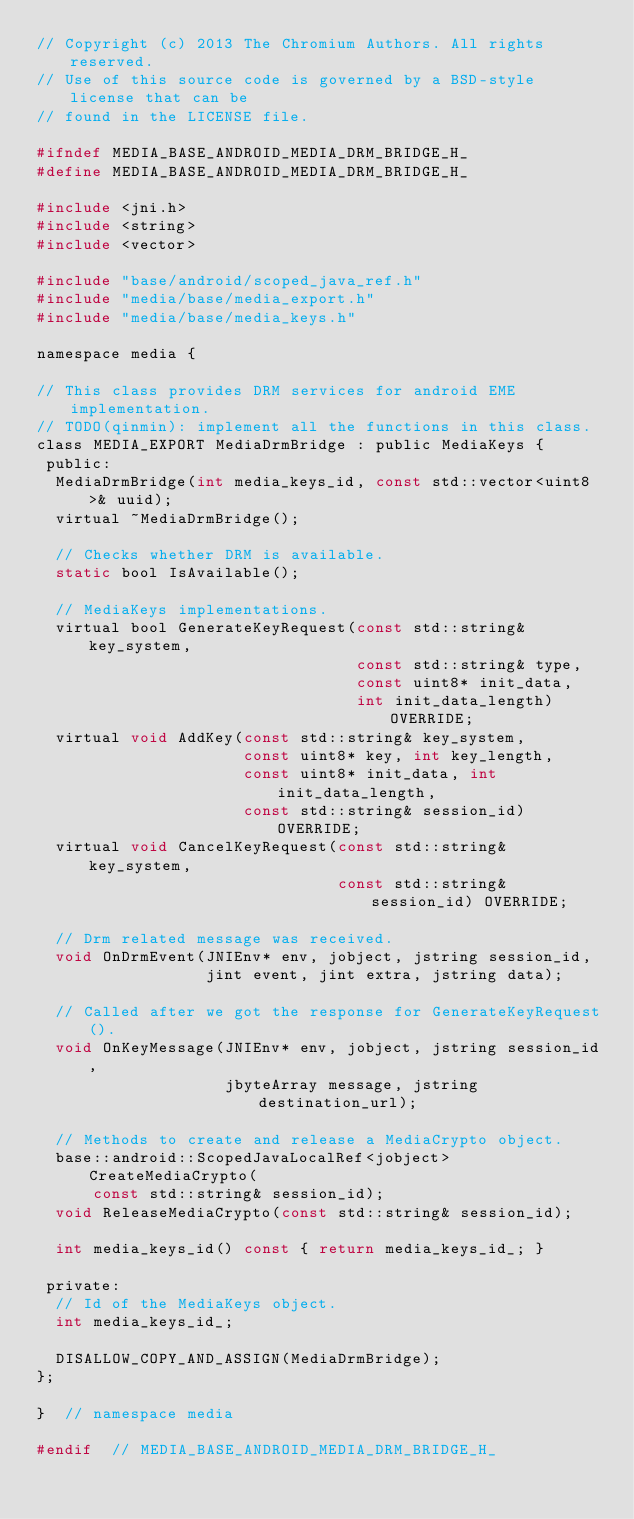Convert code to text. <code><loc_0><loc_0><loc_500><loc_500><_C_>// Copyright (c) 2013 The Chromium Authors. All rights reserved.
// Use of this source code is governed by a BSD-style license that can be
// found in the LICENSE file.

#ifndef MEDIA_BASE_ANDROID_MEDIA_DRM_BRIDGE_H_
#define MEDIA_BASE_ANDROID_MEDIA_DRM_BRIDGE_H_

#include <jni.h>
#include <string>
#include <vector>

#include "base/android/scoped_java_ref.h"
#include "media/base/media_export.h"
#include "media/base/media_keys.h"

namespace media {

// This class provides DRM services for android EME implementation.
// TODO(qinmin): implement all the functions in this class.
class MEDIA_EXPORT MediaDrmBridge : public MediaKeys {
 public:
  MediaDrmBridge(int media_keys_id, const std::vector<uint8>& uuid);
  virtual ~MediaDrmBridge();

  // Checks whether DRM is available.
  static bool IsAvailable();

  // MediaKeys implementations.
  virtual bool GenerateKeyRequest(const std::string& key_system,
                                  const std::string& type,
                                  const uint8* init_data,
                                  int init_data_length) OVERRIDE;
  virtual void AddKey(const std::string& key_system,
                      const uint8* key, int key_length,
                      const uint8* init_data, int init_data_length,
                      const std::string& session_id) OVERRIDE;
  virtual void CancelKeyRequest(const std::string& key_system,
                                const std::string& session_id) OVERRIDE;

  // Drm related message was received.
  void OnDrmEvent(JNIEnv* env, jobject, jstring session_id,
                  jint event, jint extra, jstring data);

  // Called after we got the response for GenerateKeyRequest().
  void OnKeyMessage(JNIEnv* env, jobject, jstring session_id,
                    jbyteArray message, jstring destination_url);

  // Methods to create and release a MediaCrypto object.
  base::android::ScopedJavaLocalRef<jobject> CreateMediaCrypto(
      const std::string& session_id);
  void ReleaseMediaCrypto(const std::string& session_id);

  int media_keys_id() const { return media_keys_id_; }

 private:
  // Id of the MediaKeys object.
  int media_keys_id_;

  DISALLOW_COPY_AND_ASSIGN(MediaDrmBridge);
};

}  // namespace media

#endif  // MEDIA_BASE_ANDROID_MEDIA_DRM_BRIDGE_H_
</code> 